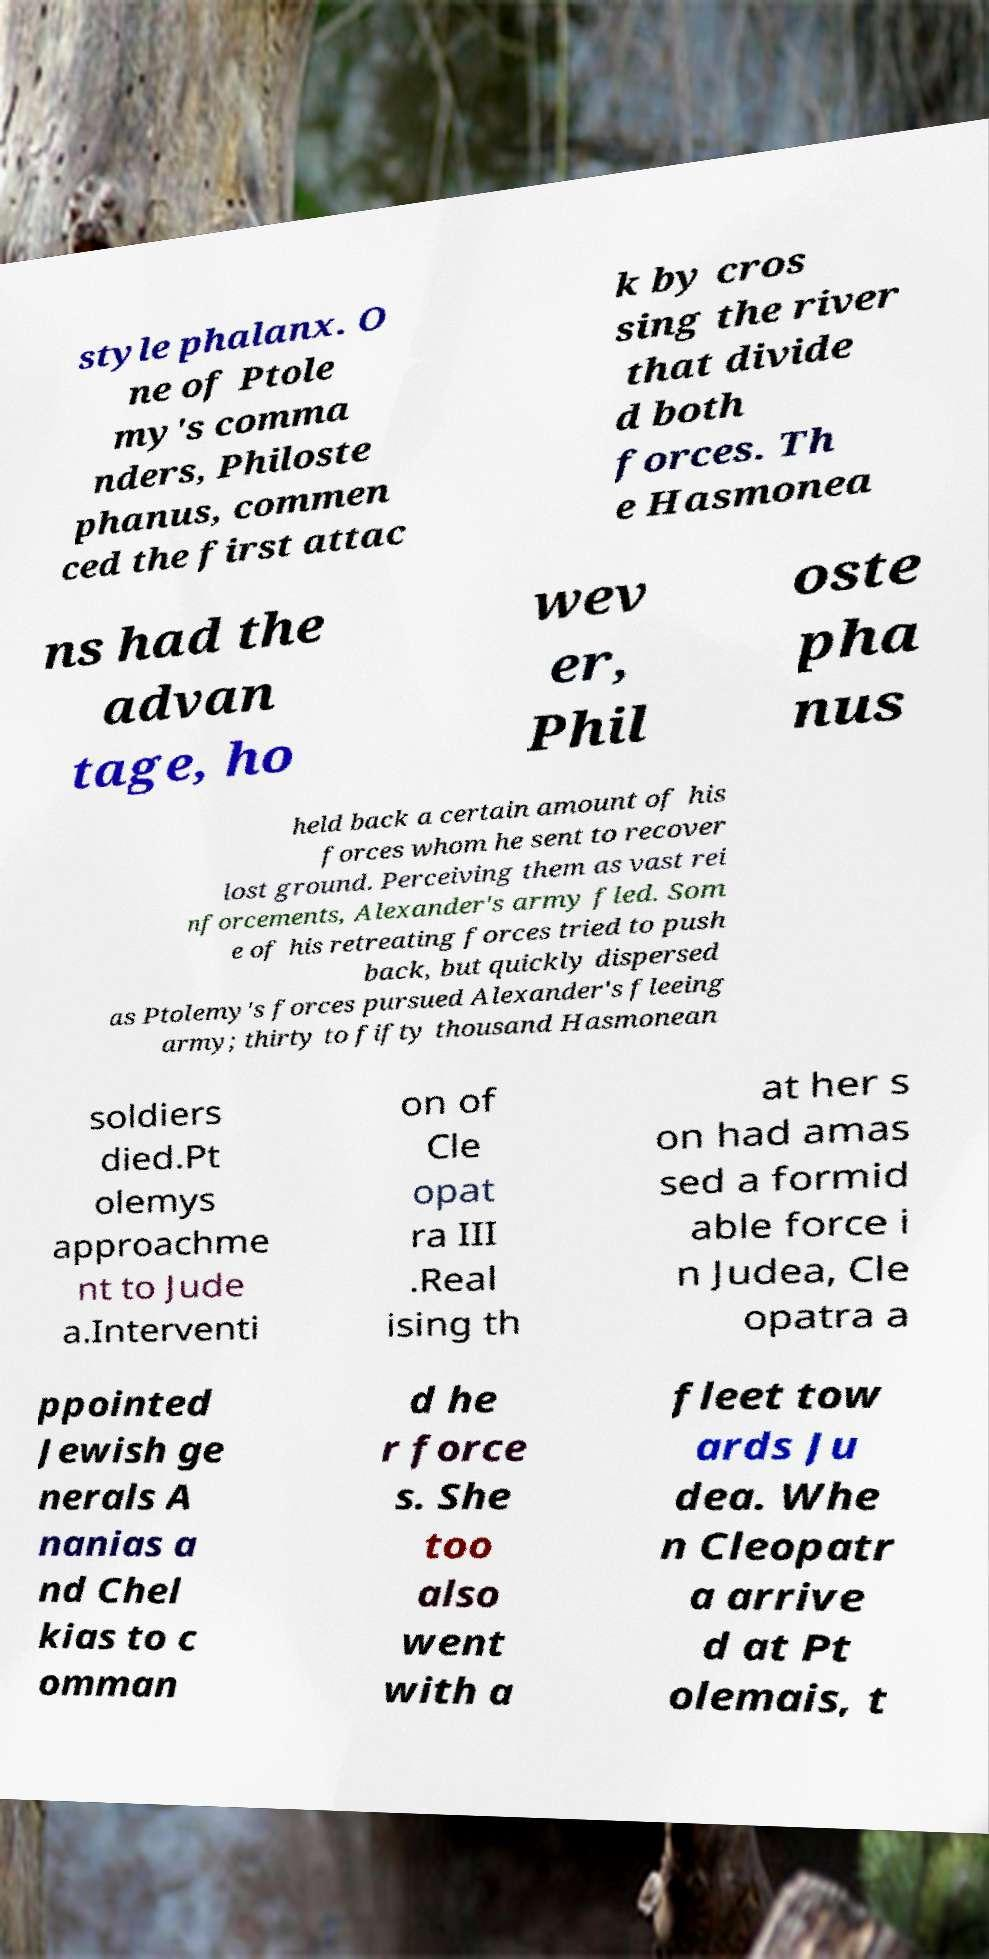Please identify and transcribe the text found in this image. style phalanx. O ne of Ptole my's comma nders, Philoste phanus, commen ced the first attac k by cros sing the river that divide d both forces. Th e Hasmonea ns had the advan tage, ho wev er, Phil oste pha nus held back a certain amount of his forces whom he sent to recover lost ground. Perceiving them as vast rei nforcements, Alexander's army fled. Som e of his retreating forces tried to push back, but quickly dispersed as Ptolemy's forces pursued Alexander's fleeing army; thirty to fifty thousand Hasmonean soldiers died.Pt olemys approachme nt to Jude a.Interventi on of Cle opat ra III .Real ising th at her s on had amas sed a formid able force i n Judea, Cle opatra a ppointed Jewish ge nerals A nanias a nd Chel kias to c omman d he r force s. She too also went with a fleet tow ards Ju dea. Whe n Cleopatr a arrive d at Pt olemais, t 